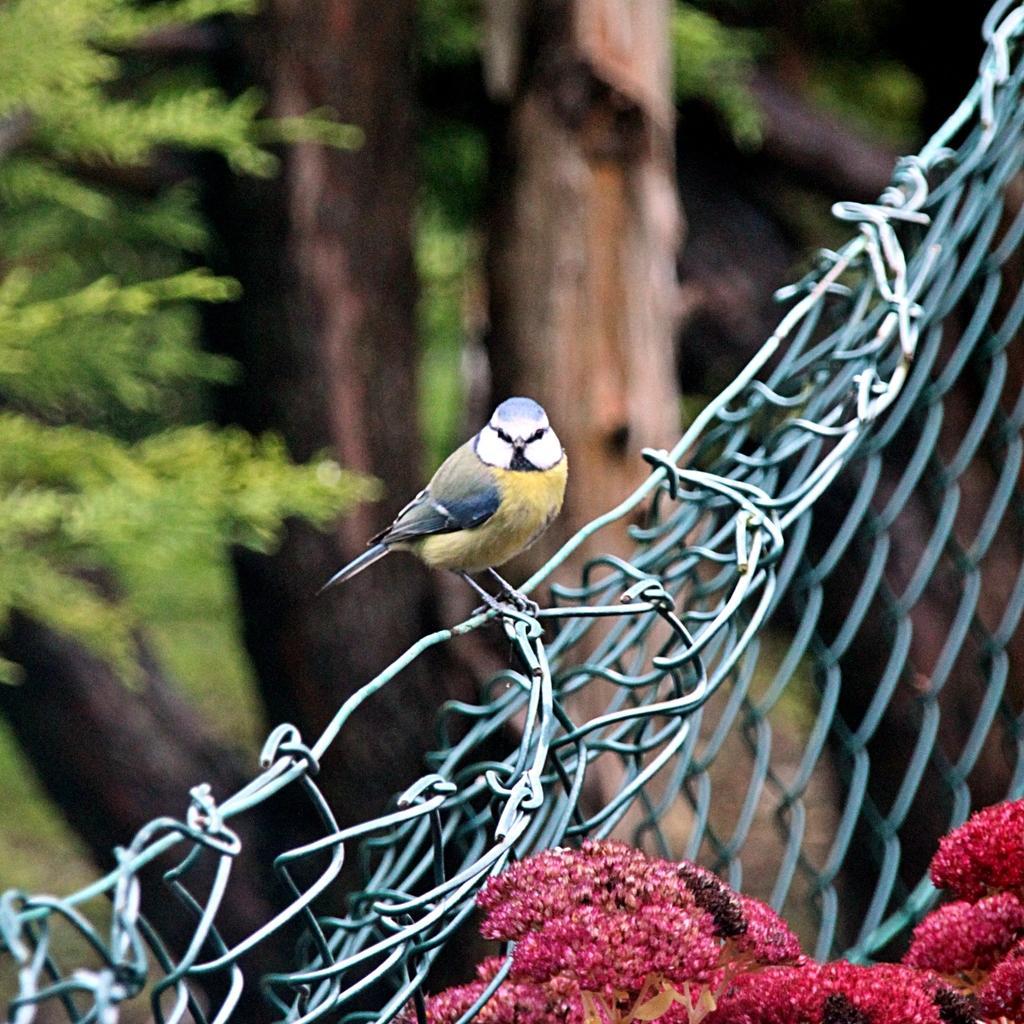Could you give a brief overview of what you see in this image? At the bottom right side of the image, we can see the flowers. In the center of the image there is a mesh. On the mesh, we can see a bird. In the background, we can see trees. 